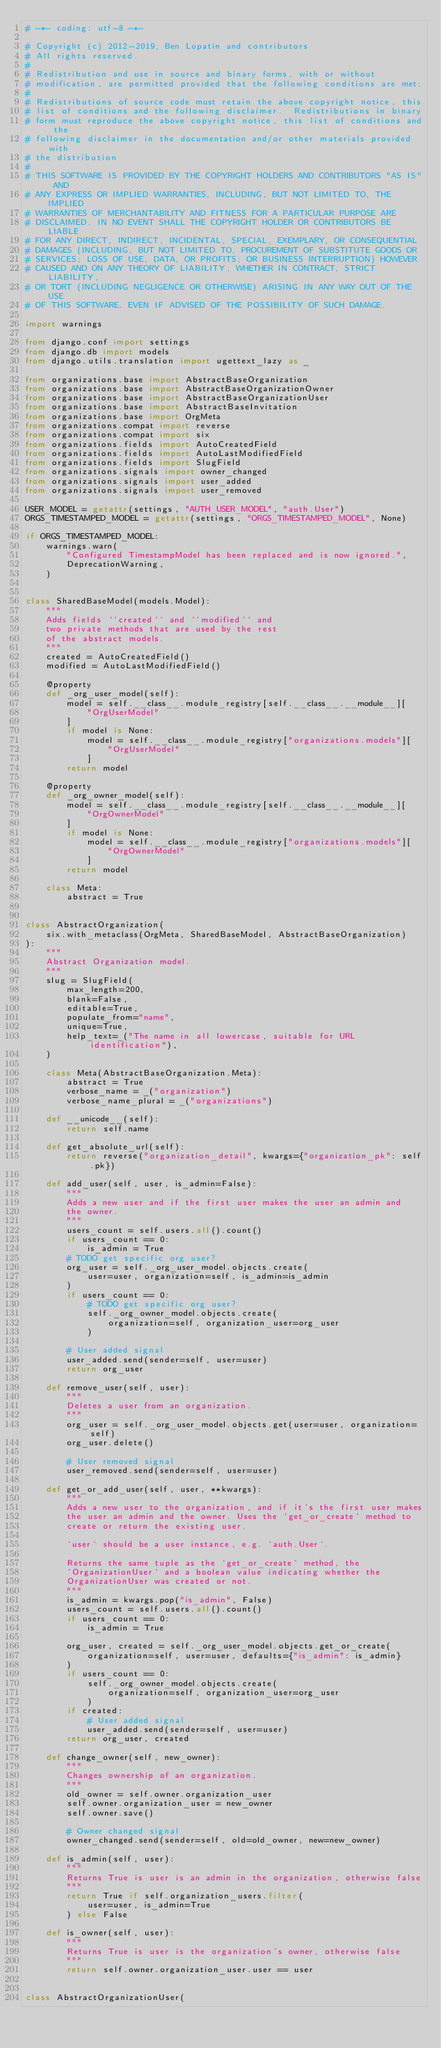<code> <loc_0><loc_0><loc_500><loc_500><_Python_># -*- coding: utf-8 -*-

# Copyright (c) 2012-2019, Ben Lopatin and contributors
# All rights reserved.
#
# Redistribution and use in source and binary forms, with or without
# modification, are permitted provided that the following conditions are met:
#
# Redistributions of source code must retain the above copyright notice, this
# list of conditions and the following disclaimer.  Redistributions in binary
# form must reproduce the above copyright notice, this list of conditions and the
# following disclaimer in the documentation and/or other materials provided with
# the distribution
#
# THIS SOFTWARE IS PROVIDED BY THE COPYRIGHT HOLDERS AND CONTRIBUTORS "AS IS" AND
# ANY EXPRESS OR IMPLIED WARRANTIES, INCLUDING, BUT NOT LIMITED TO, THE IMPLIED
# WARRANTIES OF MERCHANTABILITY AND FITNESS FOR A PARTICULAR PURPOSE ARE
# DISCLAIMED. IN NO EVENT SHALL THE COPYRIGHT HOLDER OR CONTRIBUTORS BE LIABLE
# FOR ANY DIRECT, INDIRECT, INCIDENTAL, SPECIAL, EXEMPLARY, OR CONSEQUENTIAL
# DAMAGES (INCLUDING, BUT NOT LIMITED TO, PROCUREMENT OF SUBSTITUTE GOODS OR
# SERVICES; LOSS OF USE, DATA, OR PROFITS; OR BUSINESS INTERRUPTION) HOWEVER
# CAUSED AND ON ANY THEORY OF LIABILITY, WHETHER IN CONTRACT, STRICT LIABILITY,
# OR TORT (INCLUDING NEGLIGENCE OR OTHERWISE) ARISING IN ANY WAY OUT OF THE USE
# OF THIS SOFTWARE, EVEN IF ADVISED OF THE POSSIBILITY OF SUCH DAMAGE.

import warnings

from django.conf import settings
from django.db import models
from django.utils.translation import ugettext_lazy as _

from organizations.base import AbstractBaseOrganization
from organizations.base import AbstractBaseOrganizationOwner
from organizations.base import AbstractBaseOrganizationUser
from organizations.base import AbstractBaseInvitation
from organizations.base import OrgMeta
from organizations.compat import reverse
from organizations.compat import six
from organizations.fields import AutoCreatedField
from organizations.fields import AutoLastModifiedField
from organizations.fields import SlugField
from organizations.signals import owner_changed
from organizations.signals import user_added
from organizations.signals import user_removed

USER_MODEL = getattr(settings, "AUTH_USER_MODEL", "auth.User")
ORGS_TIMESTAMPED_MODEL = getattr(settings, "ORGS_TIMESTAMPED_MODEL", None)

if ORGS_TIMESTAMPED_MODEL:
    warnings.warn(
        "Configured TimestampModel has been replaced and is now ignored.",
        DeprecationWarning,
    )


class SharedBaseModel(models.Model):
    """
    Adds fields ``created`` and ``modified`` and
    two private methods that are used by the rest
    of the abstract models.
    """
    created = AutoCreatedField()
    modified = AutoLastModifiedField()

    @property
    def _org_user_model(self):
        model = self.__class__.module_registry[self.__class__.__module__][
            "OrgUserModel"
        ]
        if model is None:
            model = self.__class__.module_registry["organizations.models"][
                "OrgUserModel"
            ]
        return model

    @property
    def _org_owner_model(self):
        model = self.__class__.module_registry[self.__class__.__module__][
            "OrgOwnerModel"
        ]
        if model is None:
            model = self.__class__.module_registry["organizations.models"][
                "OrgOwnerModel"
            ]
        return model

    class Meta:
        abstract = True


class AbstractOrganization(
    six.with_metaclass(OrgMeta, SharedBaseModel, AbstractBaseOrganization)
):
    """
    Abstract Organization model.
    """
    slug = SlugField(
        max_length=200,
        blank=False,
        editable=True,
        populate_from="name",
        unique=True,
        help_text=_("The name in all lowercase, suitable for URL identification"),
    )

    class Meta(AbstractBaseOrganization.Meta):
        abstract = True
        verbose_name = _("organization")
        verbose_name_plural = _("organizations")

    def __unicode__(self):
        return self.name

    def get_absolute_url(self):
        return reverse("organization_detail", kwargs={"organization_pk": self.pk})

    def add_user(self, user, is_admin=False):
        """
        Adds a new user and if the first user makes the user an admin and
        the owner.
        """
        users_count = self.users.all().count()
        if users_count == 0:
            is_admin = True
        # TODO get specific org user?
        org_user = self._org_user_model.objects.create(
            user=user, organization=self, is_admin=is_admin
        )
        if users_count == 0:
            # TODO get specific org user?
            self._org_owner_model.objects.create(
                organization=self, organization_user=org_user
            )

        # User added signal
        user_added.send(sender=self, user=user)
        return org_user

    def remove_user(self, user):
        """
        Deletes a user from an organization.
        """
        org_user = self._org_user_model.objects.get(user=user, organization=self)
        org_user.delete()

        # User removed signal
        user_removed.send(sender=self, user=user)

    def get_or_add_user(self, user, **kwargs):
        """
        Adds a new user to the organization, and if it's the first user makes
        the user an admin and the owner. Uses the `get_or_create` method to
        create or return the existing user.

        `user` should be a user instance, e.g. `auth.User`.

        Returns the same tuple as the `get_or_create` method, the
        `OrganizationUser` and a boolean value indicating whether the
        OrganizationUser was created or not.
        """
        is_admin = kwargs.pop("is_admin", False)
        users_count = self.users.all().count()
        if users_count == 0:
            is_admin = True

        org_user, created = self._org_user_model.objects.get_or_create(
            organization=self, user=user, defaults={"is_admin": is_admin}
        )
        if users_count == 0:
            self._org_owner_model.objects.create(
                organization=self, organization_user=org_user
            )
        if created:
            # User added signal
            user_added.send(sender=self, user=user)
        return org_user, created

    def change_owner(self, new_owner):
        """
        Changes ownership of an organization.
        """
        old_owner = self.owner.organization_user
        self.owner.organization_user = new_owner
        self.owner.save()

        # Owner changed signal
        owner_changed.send(sender=self, old=old_owner, new=new_owner)

    def is_admin(self, user):
        """
        Returns True is user is an admin in the organization, otherwise false
        """
        return True if self.organization_users.filter(
            user=user, is_admin=True
        ) else False

    def is_owner(self, user):
        """
        Returns True is user is the organization's owner, otherwise false
        """
        return self.owner.organization_user.user == user


class AbstractOrganizationUser(</code> 